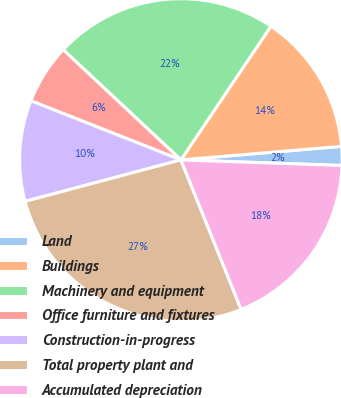Convert chart to OTSL. <chart><loc_0><loc_0><loc_500><loc_500><pie_chart><fcel>Land<fcel>Buildings<fcel>Machinery and equipment<fcel>Office furniture and fixtures<fcel>Construction-in-progress<fcel>Total property plant and<fcel>Accumulated depreciation<nl><fcel>1.89%<fcel>14.23%<fcel>22.46%<fcel>6.0%<fcel>10.12%<fcel>26.96%<fcel>18.35%<nl></chart> 